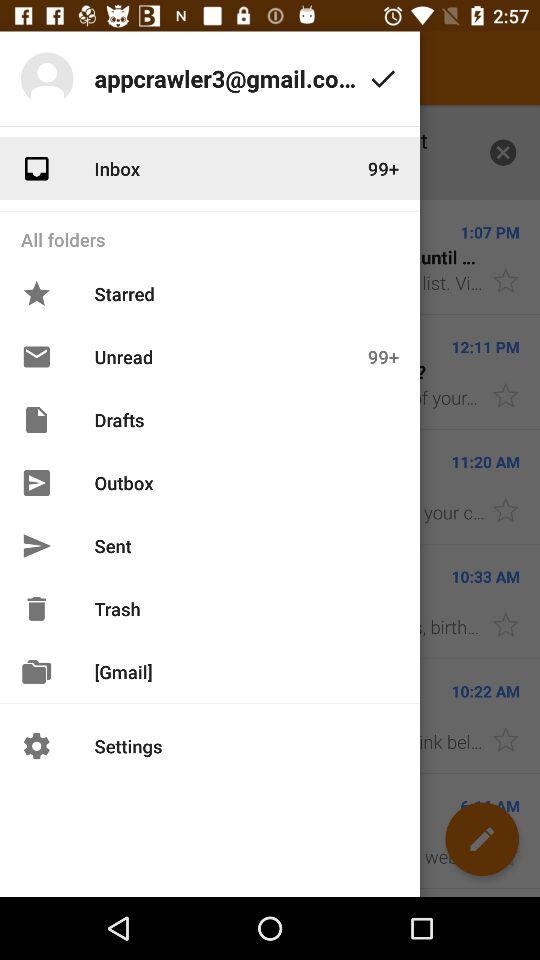What is the user's email address? The user's email address is "appcrawler3@gmail.co...". 